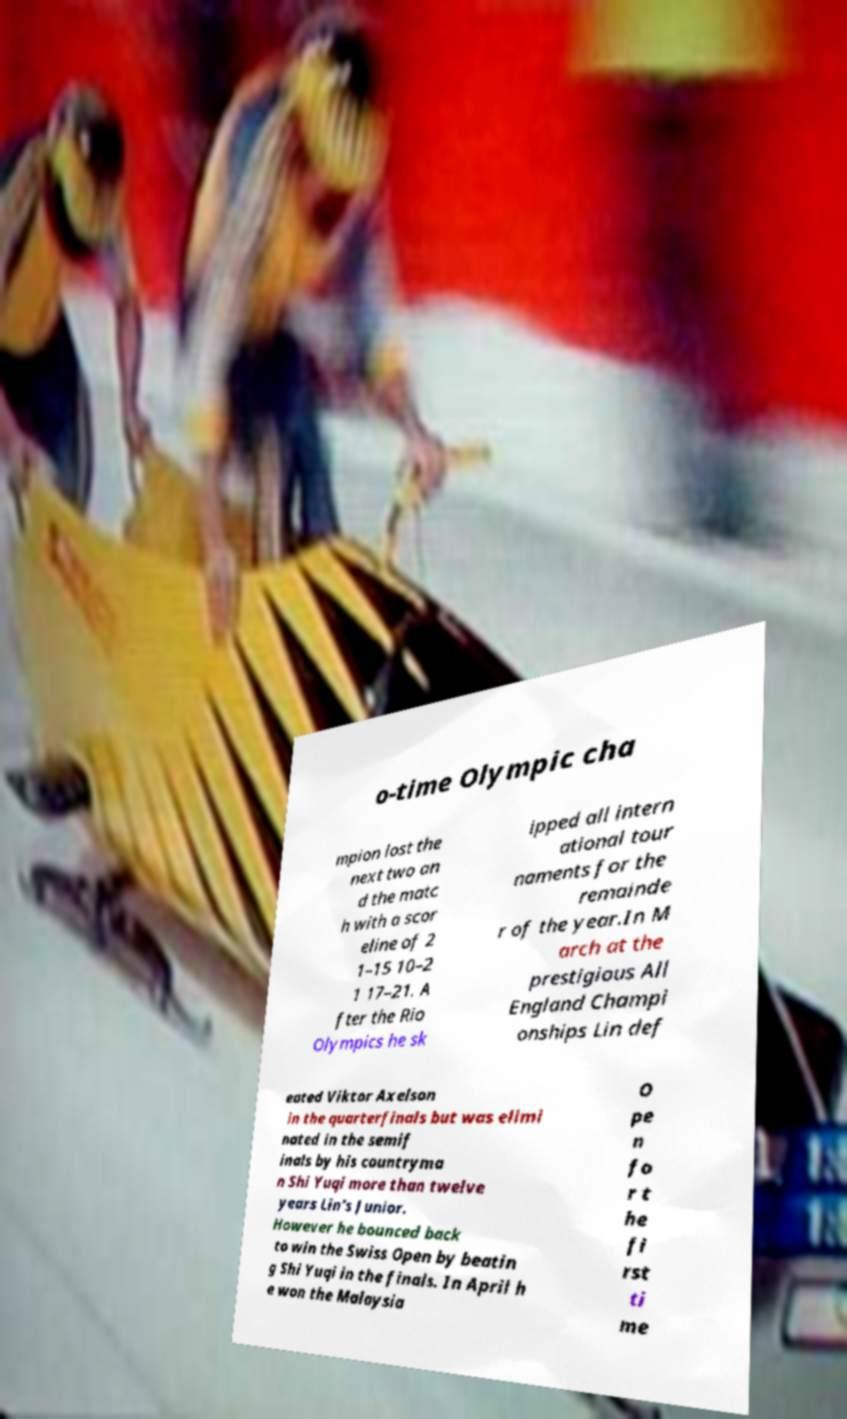Please read and relay the text visible in this image. What does it say? o-time Olympic cha mpion lost the next two an d the matc h with a scor eline of 2 1–15 10–2 1 17–21. A fter the Rio Olympics he sk ipped all intern ational tour naments for the remainde r of the year.In M arch at the prestigious All England Champi onships Lin def eated Viktor Axelson in the quarterfinals but was elimi nated in the semif inals by his countryma n Shi Yuqi more than twelve years Lin's Junior. However he bounced back to win the Swiss Open by beatin g Shi Yuqi in the finals. In April h e won the Malaysia O pe n fo r t he fi rst ti me 